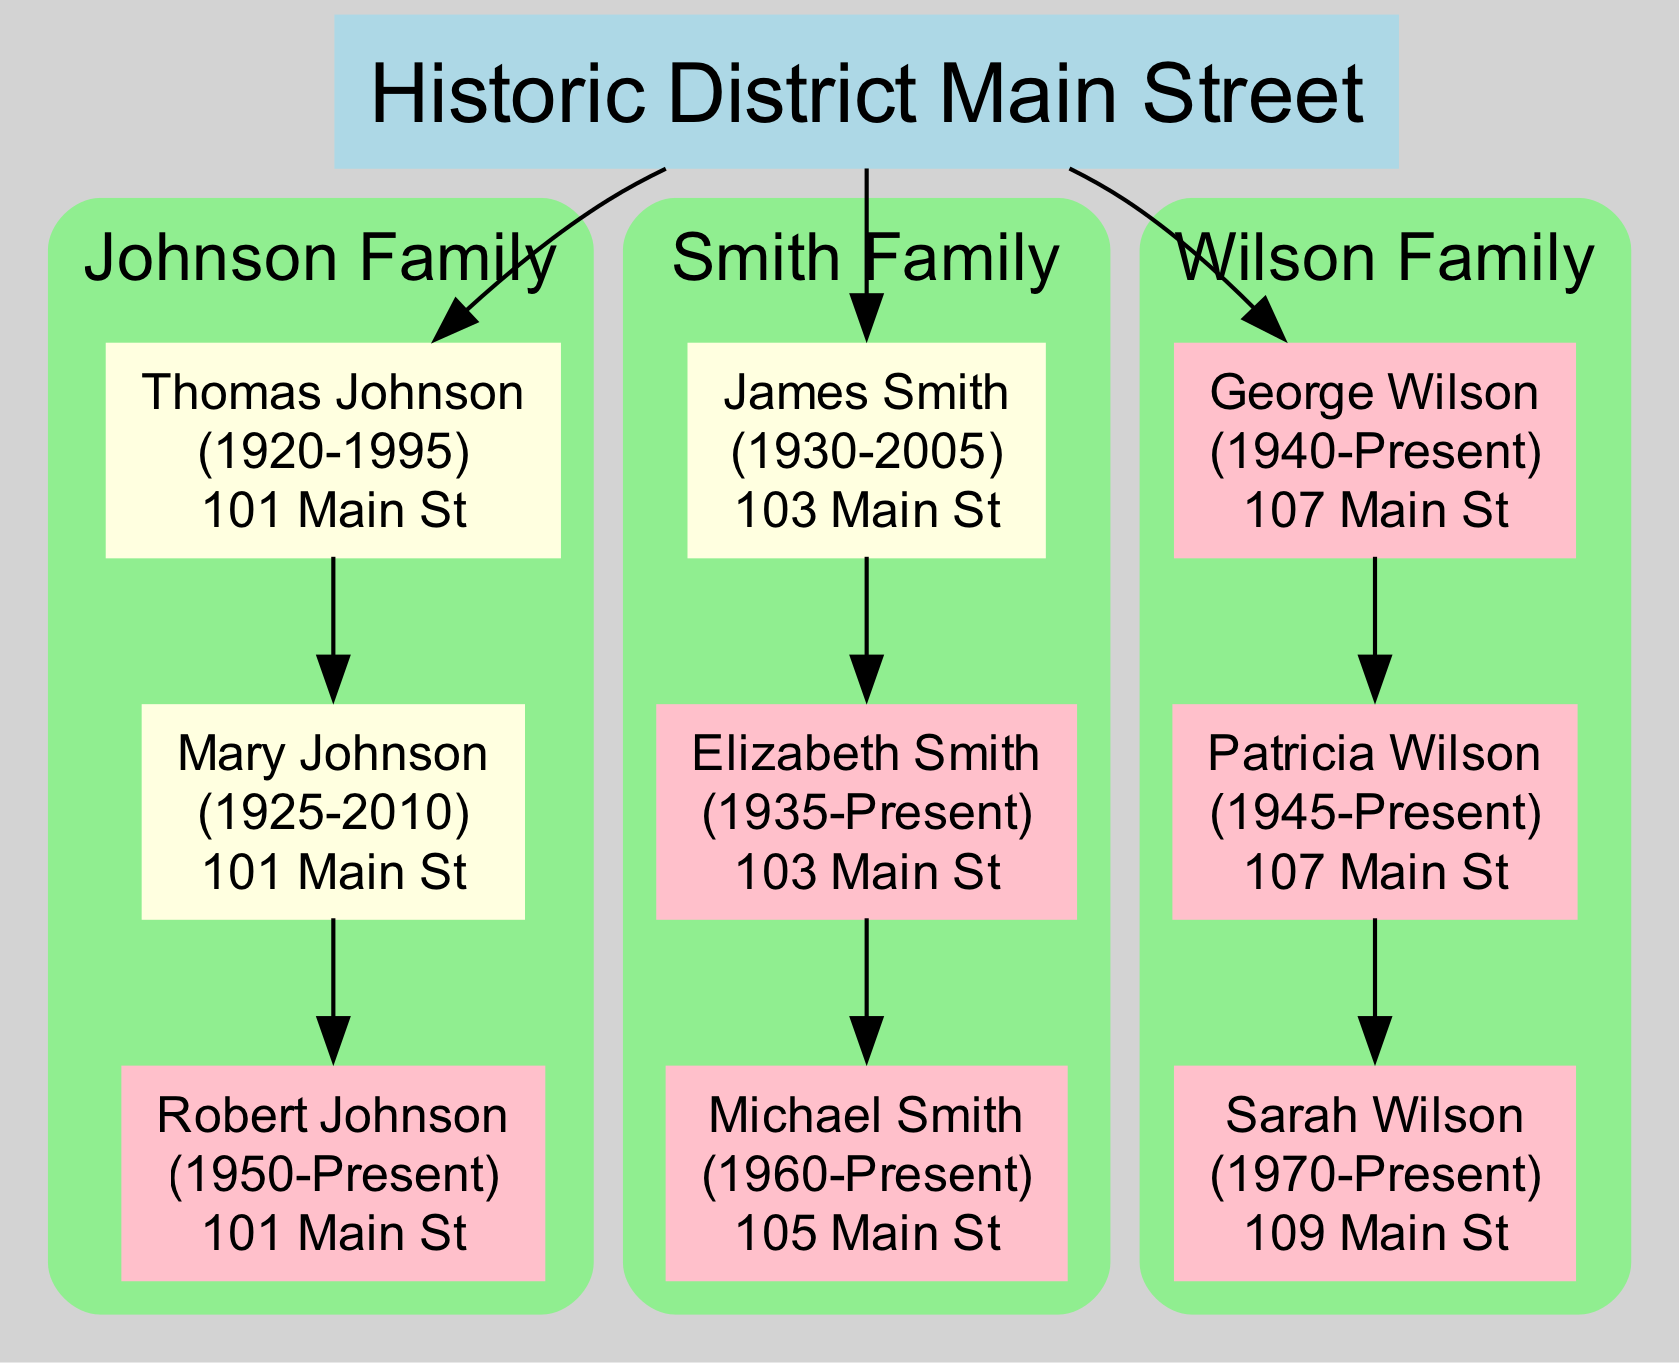What property did Thomas Johnson own? Thomas Johnson is a member of the Johnson family, and according to the diagram, his property is listed as "101 Main St."
Answer: 101 Main St How many members are in the Smith Family? The Smith Family has three members: James Smith, Elizabeth Smith, and Michael Smith. This can be counted directly from the nodes under the Smith Family subgraph.
Answer: 3 Which family has a member born in 1945? In the diagram, Patricia Wilson, a member of the Wilson Family, was born in 1945. This requires identifying the Wilson Family and scanning through their members for the birth year.
Answer: Wilson Family What is the death year of Mary Johnson? Mary Johnson is indicated in the diagram with a death year of 2010, which is shown near her name in the Johnson family node.
Answer: 2010 Which property is owned by Sarah Wilson? The diagram shows Sarah Wilson as being the owner of "109 Main St." This involves checking the node labeled for Sarah Wilson in the Wilson Family section.
Answer: 109 Main St How many properties are associated with the Smith Family? The Smith Family has members that own "103 Main St" and "105 Main St," which leads to a total of two distinct properties associated with this family upon reviewing their nodes.
Answer: 2 What is the birth year of Robert Johnson? Robert Johnson's birth year is listed as 1950 in the diagram, as indicated directly in his family node.
Answer: 1950 Who owns the property located at 103 Main St? James Smith is noted as the owner of "103 Main St." This can be determined from the node labeled with James Smith’s information in the Smith Family.
Answer: James Smith 